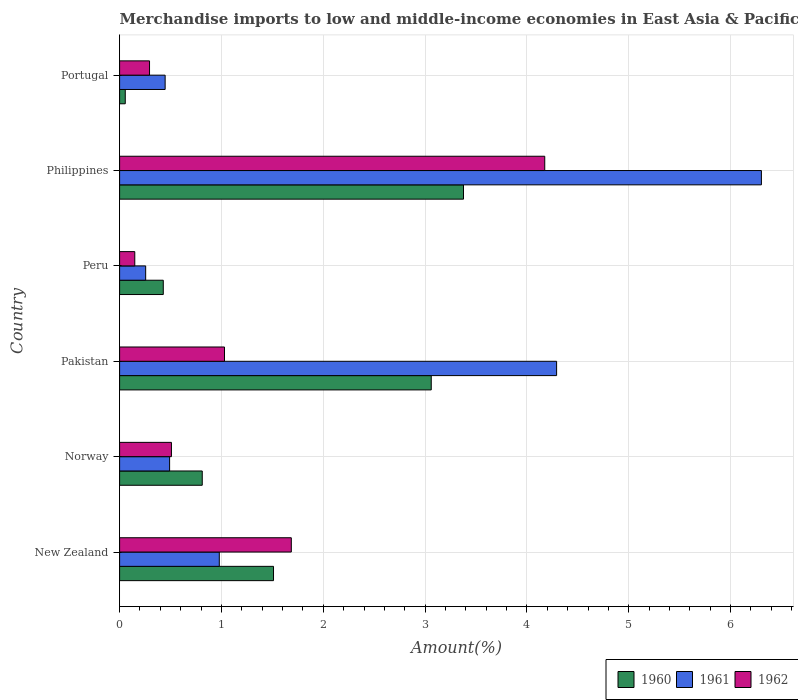How many different coloured bars are there?
Offer a very short reply. 3. How many groups of bars are there?
Provide a succinct answer. 6. Are the number of bars per tick equal to the number of legend labels?
Provide a succinct answer. Yes. Are the number of bars on each tick of the Y-axis equal?
Your response must be concise. Yes. What is the percentage of amount earned from merchandise imports in 1960 in Pakistan?
Your answer should be very brief. 3.06. Across all countries, what is the maximum percentage of amount earned from merchandise imports in 1960?
Make the answer very short. 3.38. Across all countries, what is the minimum percentage of amount earned from merchandise imports in 1962?
Make the answer very short. 0.15. In which country was the percentage of amount earned from merchandise imports in 1960 minimum?
Ensure brevity in your answer.  Portugal. What is the total percentage of amount earned from merchandise imports in 1960 in the graph?
Make the answer very short. 9.25. What is the difference between the percentage of amount earned from merchandise imports in 1961 in Norway and that in Philippines?
Keep it short and to the point. -5.81. What is the difference between the percentage of amount earned from merchandise imports in 1960 in Pakistan and the percentage of amount earned from merchandise imports in 1962 in Norway?
Provide a succinct answer. 2.55. What is the average percentage of amount earned from merchandise imports in 1961 per country?
Give a very brief answer. 2.13. What is the difference between the percentage of amount earned from merchandise imports in 1961 and percentage of amount earned from merchandise imports in 1960 in Norway?
Your response must be concise. -0.32. What is the ratio of the percentage of amount earned from merchandise imports in 1962 in Philippines to that in Portugal?
Ensure brevity in your answer.  14.2. What is the difference between the highest and the second highest percentage of amount earned from merchandise imports in 1960?
Give a very brief answer. 0.32. What is the difference between the highest and the lowest percentage of amount earned from merchandise imports in 1962?
Give a very brief answer. 4.03. In how many countries, is the percentage of amount earned from merchandise imports in 1961 greater than the average percentage of amount earned from merchandise imports in 1961 taken over all countries?
Your answer should be very brief. 2. Is the sum of the percentage of amount earned from merchandise imports in 1961 in Pakistan and Philippines greater than the maximum percentage of amount earned from merchandise imports in 1960 across all countries?
Ensure brevity in your answer.  Yes. What does the 3rd bar from the bottom in New Zealand represents?
Give a very brief answer. 1962. Are all the bars in the graph horizontal?
Your answer should be compact. Yes. How many countries are there in the graph?
Your answer should be compact. 6. Does the graph contain any zero values?
Your answer should be very brief. No. Where does the legend appear in the graph?
Give a very brief answer. Bottom right. How many legend labels are there?
Ensure brevity in your answer.  3. How are the legend labels stacked?
Your answer should be compact. Horizontal. What is the title of the graph?
Your response must be concise. Merchandise imports to low and middle-income economies in East Asia & Pacific. Does "2001" appear as one of the legend labels in the graph?
Your response must be concise. No. What is the label or title of the X-axis?
Keep it short and to the point. Amount(%). What is the Amount(%) of 1960 in New Zealand?
Offer a very short reply. 1.51. What is the Amount(%) of 1961 in New Zealand?
Give a very brief answer. 0.98. What is the Amount(%) in 1962 in New Zealand?
Provide a succinct answer. 1.69. What is the Amount(%) in 1960 in Norway?
Provide a succinct answer. 0.81. What is the Amount(%) in 1961 in Norway?
Provide a succinct answer. 0.49. What is the Amount(%) in 1962 in Norway?
Provide a succinct answer. 0.51. What is the Amount(%) of 1960 in Pakistan?
Make the answer very short. 3.06. What is the Amount(%) in 1961 in Pakistan?
Provide a succinct answer. 4.29. What is the Amount(%) of 1962 in Pakistan?
Ensure brevity in your answer.  1.03. What is the Amount(%) of 1960 in Peru?
Make the answer very short. 0.43. What is the Amount(%) in 1961 in Peru?
Offer a very short reply. 0.26. What is the Amount(%) in 1962 in Peru?
Your answer should be compact. 0.15. What is the Amount(%) of 1960 in Philippines?
Offer a very short reply. 3.38. What is the Amount(%) in 1961 in Philippines?
Offer a terse response. 6.3. What is the Amount(%) in 1962 in Philippines?
Make the answer very short. 4.18. What is the Amount(%) in 1960 in Portugal?
Keep it short and to the point. 0.06. What is the Amount(%) in 1961 in Portugal?
Provide a short and direct response. 0.45. What is the Amount(%) in 1962 in Portugal?
Make the answer very short. 0.29. Across all countries, what is the maximum Amount(%) of 1960?
Your answer should be very brief. 3.38. Across all countries, what is the maximum Amount(%) of 1961?
Make the answer very short. 6.3. Across all countries, what is the maximum Amount(%) of 1962?
Give a very brief answer. 4.18. Across all countries, what is the minimum Amount(%) of 1960?
Make the answer very short. 0.06. Across all countries, what is the minimum Amount(%) of 1961?
Your response must be concise. 0.26. Across all countries, what is the minimum Amount(%) of 1962?
Offer a terse response. 0.15. What is the total Amount(%) of 1960 in the graph?
Your answer should be compact. 9.25. What is the total Amount(%) of 1961 in the graph?
Provide a succinct answer. 12.77. What is the total Amount(%) in 1962 in the graph?
Offer a very short reply. 7.84. What is the difference between the Amount(%) of 1960 in New Zealand and that in Norway?
Keep it short and to the point. 0.7. What is the difference between the Amount(%) of 1961 in New Zealand and that in Norway?
Your response must be concise. 0.49. What is the difference between the Amount(%) in 1962 in New Zealand and that in Norway?
Ensure brevity in your answer.  1.18. What is the difference between the Amount(%) of 1960 in New Zealand and that in Pakistan?
Give a very brief answer. -1.55. What is the difference between the Amount(%) in 1961 in New Zealand and that in Pakistan?
Offer a very short reply. -3.31. What is the difference between the Amount(%) in 1962 in New Zealand and that in Pakistan?
Provide a short and direct response. 0.66. What is the difference between the Amount(%) in 1960 in New Zealand and that in Peru?
Your answer should be very brief. 1.08. What is the difference between the Amount(%) in 1961 in New Zealand and that in Peru?
Offer a terse response. 0.72. What is the difference between the Amount(%) of 1962 in New Zealand and that in Peru?
Your response must be concise. 1.54. What is the difference between the Amount(%) in 1960 in New Zealand and that in Philippines?
Keep it short and to the point. -1.87. What is the difference between the Amount(%) in 1961 in New Zealand and that in Philippines?
Give a very brief answer. -5.32. What is the difference between the Amount(%) in 1962 in New Zealand and that in Philippines?
Make the answer very short. -2.49. What is the difference between the Amount(%) of 1960 in New Zealand and that in Portugal?
Offer a very short reply. 1.46. What is the difference between the Amount(%) of 1961 in New Zealand and that in Portugal?
Offer a very short reply. 0.53. What is the difference between the Amount(%) in 1962 in New Zealand and that in Portugal?
Offer a very short reply. 1.39. What is the difference between the Amount(%) of 1960 in Norway and that in Pakistan?
Provide a succinct answer. -2.25. What is the difference between the Amount(%) in 1961 in Norway and that in Pakistan?
Your answer should be compact. -3.8. What is the difference between the Amount(%) of 1962 in Norway and that in Pakistan?
Provide a succinct answer. -0.52. What is the difference between the Amount(%) in 1960 in Norway and that in Peru?
Ensure brevity in your answer.  0.38. What is the difference between the Amount(%) in 1961 in Norway and that in Peru?
Give a very brief answer. 0.24. What is the difference between the Amount(%) in 1962 in Norway and that in Peru?
Make the answer very short. 0.36. What is the difference between the Amount(%) in 1960 in Norway and that in Philippines?
Ensure brevity in your answer.  -2.57. What is the difference between the Amount(%) of 1961 in Norway and that in Philippines?
Provide a succinct answer. -5.81. What is the difference between the Amount(%) in 1962 in Norway and that in Philippines?
Offer a terse response. -3.67. What is the difference between the Amount(%) of 1960 in Norway and that in Portugal?
Your answer should be compact. 0.76. What is the difference between the Amount(%) in 1961 in Norway and that in Portugal?
Make the answer very short. 0.04. What is the difference between the Amount(%) of 1962 in Norway and that in Portugal?
Offer a terse response. 0.22. What is the difference between the Amount(%) of 1960 in Pakistan and that in Peru?
Ensure brevity in your answer.  2.63. What is the difference between the Amount(%) of 1961 in Pakistan and that in Peru?
Provide a succinct answer. 4.04. What is the difference between the Amount(%) in 1962 in Pakistan and that in Peru?
Offer a terse response. 0.88. What is the difference between the Amount(%) in 1960 in Pakistan and that in Philippines?
Provide a short and direct response. -0.32. What is the difference between the Amount(%) of 1961 in Pakistan and that in Philippines?
Provide a short and direct response. -2.01. What is the difference between the Amount(%) of 1962 in Pakistan and that in Philippines?
Make the answer very short. -3.15. What is the difference between the Amount(%) of 1960 in Pakistan and that in Portugal?
Give a very brief answer. 3. What is the difference between the Amount(%) of 1961 in Pakistan and that in Portugal?
Give a very brief answer. 3.84. What is the difference between the Amount(%) in 1962 in Pakistan and that in Portugal?
Your answer should be compact. 0.74. What is the difference between the Amount(%) in 1960 in Peru and that in Philippines?
Ensure brevity in your answer.  -2.95. What is the difference between the Amount(%) of 1961 in Peru and that in Philippines?
Offer a very short reply. -6.05. What is the difference between the Amount(%) in 1962 in Peru and that in Philippines?
Provide a short and direct response. -4.03. What is the difference between the Amount(%) of 1960 in Peru and that in Portugal?
Give a very brief answer. 0.37. What is the difference between the Amount(%) of 1961 in Peru and that in Portugal?
Offer a very short reply. -0.19. What is the difference between the Amount(%) in 1962 in Peru and that in Portugal?
Give a very brief answer. -0.14. What is the difference between the Amount(%) in 1960 in Philippines and that in Portugal?
Offer a very short reply. 3.32. What is the difference between the Amount(%) in 1961 in Philippines and that in Portugal?
Provide a succinct answer. 5.86. What is the difference between the Amount(%) of 1962 in Philippines and that in Portugal?
Your answer should be very brief. 3.88. What is the difference between the Amount(%) in 1960 in New Zealand and the Amount(%) in 1961 in Norway?
Ensure brevity in your answer.  1.02. What is the difference between the Amount(%) in 1960 in New Zealand and the Amount(%) in 1962 in Norway?
Offer a terse response. 1. What is the difference between the Amount(%) in 1961 in New Zealand and the Amount(%) in 1962 in Norway?
Your response must be concise. 0.47. What is the difference between the Amount(%) of 1960 in New Zealand and the Amount(%) of 1961 in Pakistan?
Ensure brevity in your answer.  -2.78. What is the difference between the Amount(%) in 1960 in New Zealand and the Amount(%) in 1962 in Pakistan?
Ensure brevity in your answer.  0.48. What is the difference between the Amount(%) of 1961 in New Zealand and the Amount(%) of 1962 in Pakistan?
Keep it short and to the point. -0.05. What is the difference between the Amount(%) in 1960 in New Zealand and the Amount(%) in 1961 in Peru?
Make the answer very short. 1.26. What is the difference between the Amount(%) in 1960 in New Zealand and the Amount(%) in 1962 in Peru?
Provide a short and direct response. 1.36. What is the difference between the Amount(%) of 1961 in New Zealand and the Amount(%) of 1962 in Peru?
Provide a succinct answer. 0.83. What is the difference between the Amount(%) in 1960 in New Zealand and the Amount(%) in 1961 in Philippines?
Your answer should be compact. -4.79. What is the difference between the Amount(%) of 1960 in New Zealand and the Amount(%) of 1962 in Philippines?
Provide a short and direct response. -2.66. What is the difference between the Amount(%) of 1961 in New Zealand and the Amount(%) of 1962 in Philippines?
Offer a very short reply. -3.2. What is the difference between the Amount(%) of 1960 in New Zealand and the Amount(%) of 1961 in Portugal?
Make the answer very short. 1.06. What is the difference between the Amount(%) in 1960 in New Zealand and the Amount(%) in 1962 in Portugal?
Make the answer very short. 1.22. What is the difference between the Amount(%) of 1961 in New Zealand and the Amount(%) of 1962 in Portugal?
Provide a short and direct response. 0.69. What is the difference between the Amount(%) of 1960 in Norway and the Amount(%) of 1961 in Pakistan?
Give a very brief answer. -3.48. What is the difference between the Amount(%) of 1960 in Norway and the Amount(%) of 1962 in Pakistan?
Offer a very short reply. -0.22. What is the difference between the Amount(%) of 1961 in Norway and the Amount(%) of 1962 in Pakistan?
Your response must be concise. -0.54. What is the difference between the Amount(%) in 1960 in Norway and the Amount(%) in 1961 in Peru?
Your answer should be compact. 0.56. What is the difference between the Amount(%) in 1960 in Norway and the Amount(%) in 1962 in Peru?
Your answer should be compact. 0.66. What is the difference between the Amount(%) in 1961 in Norway and the Amount(%) in 1962 in Peru?
Your answer should be compact. 0.34. What is the difference between the Amount(%) in 1960 in Norway and the Amount(%) in 1961 in Philippines?
Your response must be concise. -5.49. What is the difference between the Amount(%) of 1960 in Norway and the Amount(%) of 1962 in Philippines?
Offer a terse response. -3.36. What is the difference between the Amount(%) of 1961 in Norway and the Amount(%) of 1962 in Philippines?
Provide a succinct answer. -3.68. What is the difference between the Amount(%) in 1960 in Norway and the Amount(%) in 1961 in Portugal?
Provide a succinct answer. 0.36. What is the difference between the Amount(%) in 1960 in Norway and the Amount(%) in 1962 in Portugal?
Provide a short and direct response. 0.52. What is the difference between the Amount(%) of 1961 in Norway and the Amount(%) of 1962 in Portugal?
Offer a terse response. 0.2. What is the difference between the Amount(%) of 1960 in Pakistan and the Amount(%) of 1961 in Peru?
Keep it short and to the point. 2.8. What is the difference between the Amount(%) in 1960 in Pakistan and the Amount(%) in 1962 in Peru?
Your answer should be compact. 2.91. What is the difference between the Amount(%) in 1961 in Pakistan and the Amount(%) in 1962 in Peru?
Offer a terse response. 4.14. What is the difference between the Amount(%) of 1960 in Pakistan and the Amount(%) of 1961 in Philippines?
Provide a short and direct response. -3.24. What is the difference between the Amount(%) of 1960 in Pakistan and the Amount(%) of 1962 in Philippines?
Give a very brief answer. -1.11. What is the difference between the Amount(%) of 1961 in Pakistan and the Amount(%) of 1962 in Philippines?
Provide a short and direct response. 0.12. What is the difference between the Amount(%) of 1960 in Pakistan and the Amount(%) of 1961 in Portugal?
Provide a short and direct response. 2.61. What is the difference between the Amount(%) of 1960 in Pakistan and the Amount(%) of 1962 in Portugal?
Your answer should be very brief. 2.77. What is the difference between the Amount(%) of 1961 in Pakistan and the Amount(%) of 1962 in Portugal?
Offer a terse response. 4. What is the difference between the Amount(%) of 1960 in Peru and the Amount(%) of 1961 in Philippines?
Offer a terse response. -5.87. What is the difference between the Amount(%) in 1960 in Peru and the Amount(%) in 1962 in Philippines?
Make the answer very short. -3.75. What is the difference between the Amount(%) in 1961 in Peru and the Amount(%) in 1962 in Philippines?
Your answer should be compact. -3.92. What is the difference between the Amount(%) in 1960 in Peru and the Amount(%) in 1961 in Portugal?
Provide a short and direct response. -0.02. What is the difference between the Amount(%) of 1960 in Peru and the Amount(%) of 1962 in Portugal?
Keep it short and to the point. 0.14. What is the difference between the Amount(%) in 1961 in Peru and the Amount(%) in 1962 in Portugal?
Your answer should be compact. -0.04. What is the difference between the Amount(%) in 1960 in Philippines and the Amount(%) in 1961 in Portugal?
Your response must be concise. 2.93. What is the difference between the Amount(%) in 1960 in Philippines and the Amount(%) in 1962 in Portugal?
Keep it short and to the point. 3.08. What is the difference between the Amount(%) of 1961 in Philippines and the Amount(%) of 1962 in Portugal?
Ensure brevity in your answer.  6.01. What is the average Amount(%) in 1960 per country?
Give a very brief answer. 1.54. What is the average Amount(%) of 1961 per country?
Keep it short and to the point. 2.13. What is the average Amount(%) in 1962 per country?
Make the answer very short. 1.31. What is the difference between the Amount(%) in 1960 and Amount(%) in 1961 in New Zealand?
Keep it short and to the point. 0.53. What is the difference between the Amount(%) of 1960 and Amount(%) of 1962 in New Zealand?
Give a very brief answer. -0.17. What is the difference between the Amount(%) in 1961 and Amount(%) in 1962 in New Zealand?
Give a very brief answer. -0.71. What is the difference between the Amount(%) in 1960 and Amount(%) in 1961 in Norway?
Your answer should be compact. 0.32. What is the difference between the Amount(%) in 1960 and Amount(%) in 1962 in Norway?
Offer a terse response. 0.3. What is the difference between the Amount(%) in 1961 and Amount(%) in 1962 in Norway?
Your answer should be very brief. -0.02. What is the difference between the Amount(%) in 1960 and Amount(%) in 1961 in Pakistan?
Your answer should be compact. -1.23. What is the difference between the Amount(%) in 1960 and Amount(%) in 1962 in Pakistan?
Offer a very short reply. 2.03. What is the difference between the Amount(%) in 1961 and Amount(%) in 1962 in Pakistan?
Keep it short and to the point. 3.26. What is the difference between the Amount(%) of 1960 and Amount(%) of 1961 in Peru?
Ensure brevity in your answer.  0.17. What is the difference between the Amount(%) of 1960 and Amount(%) of 1962 in Peru?
Your answer should be very brief. 0.28. What is the difference between the Amount(%) in 1961 and Amount(%) in 1962 in Peru?
Offer a very short reply. 0.11. What is the difference between the Amount(%) of 1960 and Amount(%) of 1961 in Philippines?
Your answer should be very brief. -2.93. What is the difference between the Amount(%) in 1960 and Amount(%) in 1962 in Philippines?
Give a very brief answer. -0.8. What is the difference between the Amount(%) of 1961 and Amount(%) of 1962 in Philippines?
Give a very brief answer. 2.13. What is the difference between the Amount(%) of 1960 and Amount(%) of 1961 in Portugal?
Your response must be concise. -0.39. What is the difference between the Amount(%) in 1960 and Amount(%) in 1962 in Portugal?
Offer a very short reply. -0.24. What is the difference between the Amount(%) in 1961 and Amount(%) in 1962 in Portugal?
Provide a short and direct response. 0.15. What is the ratio of the Amount(%) in 1960 in New Zealand to that in Norway?
Offer a very short reply. 1.86. What is the ratio of the Amount(%) of 1961 in New Zealand to that in Norway?
Give a very brief answer. 1.99. What is the ratio of the Amount(%) of 1962 in New Zealand to that in Norway?
Make the answer very short. 3.31. What is the ratio of the Amount(%) of 1960 in New Zealand to that in Pakistan?
Give a very brief answer. 0.49. What is the ratio of the Amount(%) of 1961 in New Zealand to that in Pakistan?
Offer a terse response. 0.23. What is the ratio of the Amount(%) of 1962 in New Zealand to that in Pakistan?
Offer a very short reply. 1.64. What is the ratio of the Amount(%) in 1960 in New Zealand to that in Peru?
Give a very brief answer. 3.52. What is the ratio of the Amount(%) of 1961 in New Zealand to that in Peru?
Ensure brevity in your answer.  3.82. What is the ratio of the Amount(%) in 1962 in New Zealand to that in Peru?
Provide a short and direct response. 11.31. What is the ratio of the Amount(%) of 1960 in New Zealand to that in Philippines?
Your answer should be very brief. 0.45. What is the ratio of the Amount(%) in 1961 in New Zealand to that in Philippines?
Ensure brevity in your answer.  0.16. What is the ratio of the Amount(%) of 1962 in New Zealand to that in Philippines?
Provide a succinct answer. 0.4. What is the ratio of the Amount(%) in 1960 in New Zealand to that in Portugal?
Offer a terse response. 27.18. What is the ratio of the Amount(%) of 1961 in New Zealand to that in Portugal?
Offer a terse response. 2.19. What is the ratio of the Amount(%) in 1962 in New Zealand to that in Portugal?
Your response must be concise. 5.74. What is the ratio of the Amount(%) in 1960 in Norway to that in Pakistan?
Keep it short and to the point. 0.27. What is the ratio of the Amount(%) of 1961 in Norway to that in Pakistan?
Keep it short and to the point. 0.11. What is the ratio of the Amount(%) in 1962 in Norway to that in Pakistan?
Give a very brief answer. 0.49. What is the ratio of the Amount(%) of 1960 in Norway to that in Peru?
Provide a short and direct response. 1.89. What is the ratio of the Amount(%) in 1961 in Norway to that in Peru?
Your answer should be compact. 1.92. What is the ratio of the Amount(%) of 1962 in Norway to that in Peru?
Provide a short and direct response. 3.41. What is the ratio of the Amount(%) in 1960 in Norway to that in Philippines?
Provide a short and direct response. 0.24. What is the ratio of the Amount(%) in 1961 in Norway to that in Philippines?
Ensure brevity in your answer.  0.08. What is the ratio of the Amount(%) in 1962 in Norway to that in Philippines?
Give a very brief answer. 0.12. What is the ratio of the Amount(%) of 1960 in Norway to that in Portugal?
Make the answer very short. 14.6. What is the ratio of the Amount(%) of 1961 in Norway to that in Portugal?
Make the answer very short. 1.1. What is the ratio of the Amount(%) of 1962 in Norway to that in Portugal?
Keep it short and to the point. 1.73. What is the ratio of the Amount(%) of 1960 in Pakistan to that in Peru?
Make the answer very short. 7.13. What is the ratio of the Amount(%) in 1961 in Pakistan to that in Peru?
Offer a terse response. 16.76. What is the ratio of the Amount(%) in 1962 in Pakistan to that in Peru?
Provide a short and direct response. 6.91. What is the ratio of the Amount(%) in 1960 in Pakistan to that in Philippines?
Provide a short and direct response. 0.91. What is the ratio of the Amount(%) in 1961 in Pakistan to that in Philippines?
Give a very brief answer. 0.68. What is the ratio of the Amount(%) in 1962 in Pakistan to that in Philippines?
Keep it short and to the point. 0.25. What is the ratio of the Amount(%) of 1960 in Pakistan to that in Portugal?
Offer a very short reply. 55.04. What is the ratio of the Amount(%) in 1961 in Pakistan to that in Portugal?
Keep it short and to the point. 9.6. What is the ratio of the Amount(%) of 1962 in Pakistan to that in Portugal?
Ensure brevity in your answer.  3.5. What is the ratio of the Amount(%) of 1960 in Peru to that in Philippines?
Ensure brevity in your answer.  0.13. What is the ratio of the Amount(%) in 1961 in Peru to that in Philippines?
Your answer should be compact. 0.04. What is the ratio of the Amount(%) of 1962 in Peru to that in Philippines?
Keep it short and to the point. 0.04. What is the ratio of the Amount(%) of 1960 in Peru to that in Portugal?
Offer a very short reply. 7.71. What is the ratio of the Amount(%) in 1961 in Peru to that in Portugal?
Your response must be concise. 0.57. What is the ratio of the Amount(%) in 1962 in Peru to that in Portugal?
Provide a succinct answer. 0.51. What is the ratio of the Amount(%) of 1960 in Philippines to that in Portugal?
Your response must be concise. 60.74. What is the ratio of the Amount(%) in 1961 in Philippines to that in Portugal?
Give a very brief answer. 14.09. What is the ratio of the Amount(%) of 1962 in Philippines to that in Portugal?
Offer a terse response. 14.2. What is the difference between the highest and the second highest Amount(%) of 1960?
Keep it short and to the point. 0.32. What is the difference between the highest and the second highest Amount(%) in 1961?
Give a very brief answer. 2.01. What is the difference between the highest and the second highest Amount(%) in 1962?
Make the answer very short. 2.49. What is the difference between the highest and the lowest Amount(%) in 1960?
Give a very brief answer. 3.32. What is the difference between the highest and the lowest Amount(%) in 1961?
Your answer should be compact. 6.05. What is the difference between the highest and the lowest Amount(%) of 1962?
Offer a very short reply. 4.03. 